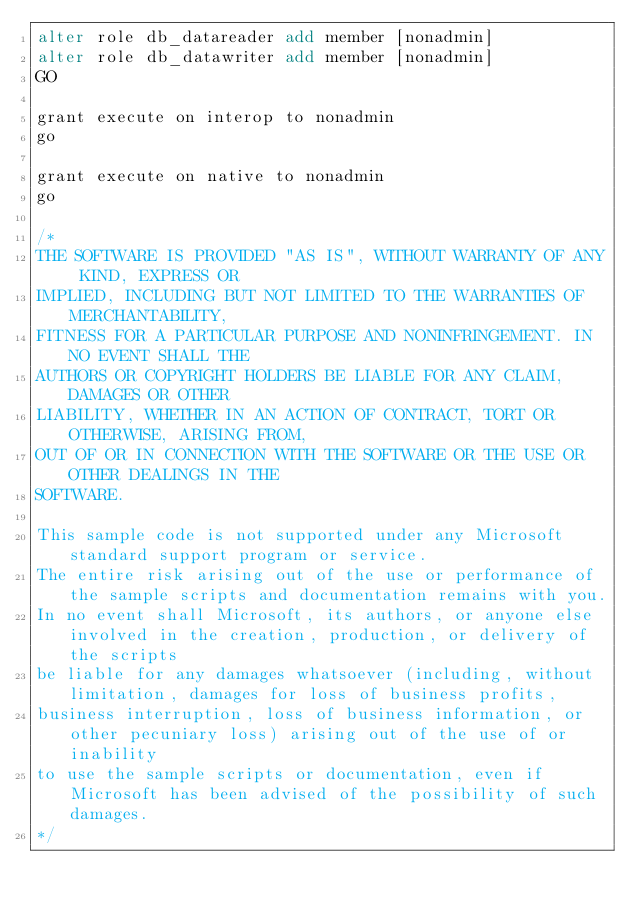Convert code to text. <code><loc_0><loc_0><loc_500><loc_500><_SQL_>alter role db_datareader add member [nonadmin]
alter role db_datawriter add member [nonadmin]
GO

grant execute on interop to nonadmin
go

grant execute on native to nonadmin
go

/*
THE SOFTWARE IS PROVIDED "AS IS", WITHOUT WARRANTY OF ANY KIND, EXPRESS OR 
IMPLIED, INCLUDING BUT NOT LIMITED TO THE WARRANTIES OF MERCHANTABILITY, 
FITNESS FOR A PARTICULAR PURPOSE AND NONINFRINGEMENT. IN NO EVENT SHALL THE 
AUTHORS OR COPYRIGHT HOLDERS BE LIABLE FOR ANY CLAIM, DAMAGES OR OTHER 
LIABILITY, WHETHER IN AN ACTION OF CONTRACT, TORT OR OTHERWISE, ARISING FROM, 
OUT OF OR IN CONNECTION WITH THE SOFTWARE OR THE USE OR OTHER DEALINGS IN THE 
SOFTWARE. 

This sample code is not supported under any Microsoft standard support program or service.  
The entire risk arising out of the use or performance of the sample scripts and documentation remains with you.  
In no event shall Microsoft, its authors, or anyone else involved in the creation, production, or delivery of the scripts 
be liable for any damages whatsoever (including, without limitation, damages for loss of business profits, 
business interruption, loss of business information, or other pecuniary loss) arising out of the use of or inability 
to use the sample scripts or documentation, even if Microsoft has been advised of the possibility of such damages. 
*/
</code> 